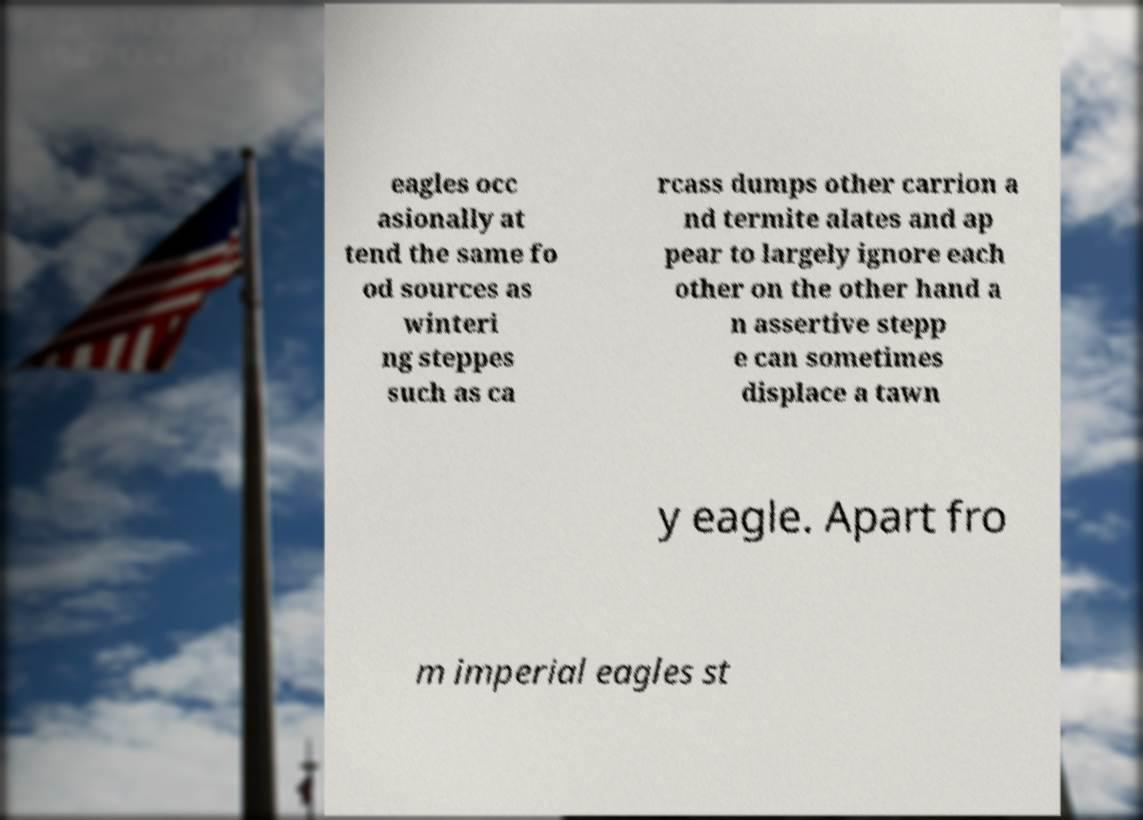Could you assist in decoding the text presented in this image and type it out clearly? eagles occ asionally at tend the same fo od sources as winteri ng steppes such as ca rcass dumps other carrion a nd termite alates and ap pear to largely ignore each other on the other hand a n assertive stepp e can sometimes displace a tawn y eagle. Apart fro m imperial eagles st 